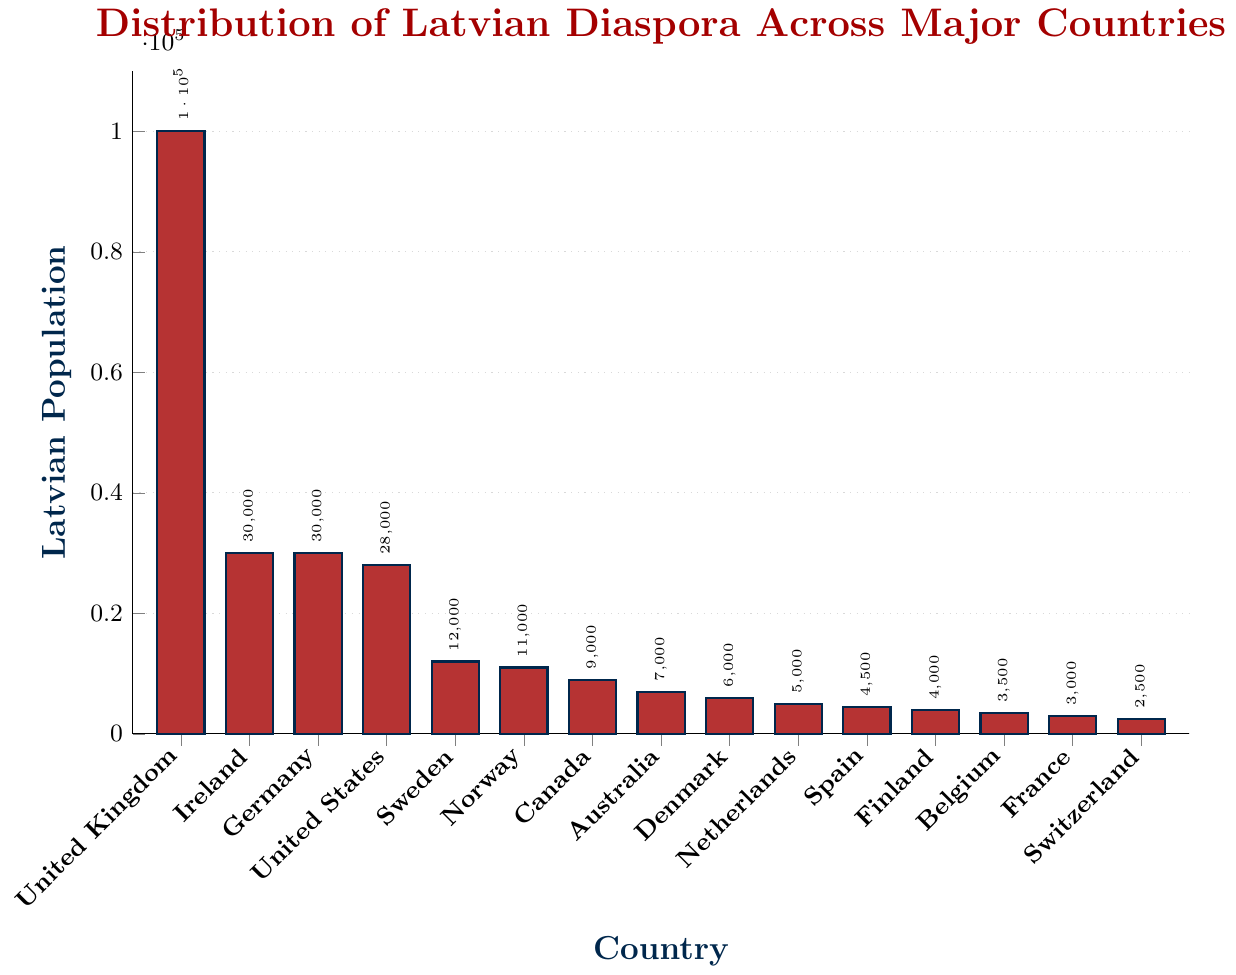What's the Latvian population in the United Kingdom? The bar for the United Kingdom is visibly the tallest, close to the maximum y-axis limit, indicating it is 100,000.
Answer: 100,000 Which country has the largest Latvian population? The United Kingdom has the tallest bar in the chart, suggesting it has the largest Latvian population.
Answer: United Kingdom Which two countries have an equal Latvian population of 30,000? Both Ireland and Germany have bars that reach up to 30,000, indicating they have equal Latvian populations.
Answer: Ireland and Germany How does the Latvian population in Sweden compare to that in Norway? The Latvian population bar for Sweden (12,000) is slightly higher than that for Norway (11,000).
Answer: Sweden is greater What's the total Latvian population in the top four countries? Add up the populations of the United Kingdom (100,000), Ireland (30,000), Germany (30,000), and the United States (28,000): 100,000 + 30,000 + 30,000 + 28,000 = 188,000.
Answer: 188,000 What is the average Latvian population across all countries listed? Sum the populations: 100,000 + 30,000 + 30,000 + 28,000 + 12,000 + 11,000 + 9,000 + 7,000 + 6,000 + 5,000 + 4,500 + 4,000 + 3,500 + 3,000 + 2,500 = 245,500. There are 15 countries. Average = 245,500 / 15 ≈ 16,367.
Answer: 16,367 By how much does the Latvian population in the United Kingdom exceed that in the United States? Subtract the population of the United States from the United Kingdom: 100,000 - 28,000 = 72,000.
Answer: 72,000 Which countries have a Latvian population less than 5,000? The countries Denmark (6,000), the Netherlands (5,000), Spain (4,500), Finland (4,000), Belgium (3,500), France (3,000), and Switzerland (2,500) have populations below 5,000.
Answer: Spain, Finland, Belgium, France, Switzerland Estimate the height ratio of the bars for the United Kingdom and Australia. The population in the United Kingdom is 100,000, while in Australia, it is 7,000. The ratio is 100,000 / 7,000 ≈ 14.29.
Answer: ~14.29 What is the difference between the Latvian populations in Canada and Australia? Subtract the population of Australia from Canada: 9,000 - 7,000 = 2,000.
Answer: 2,000 